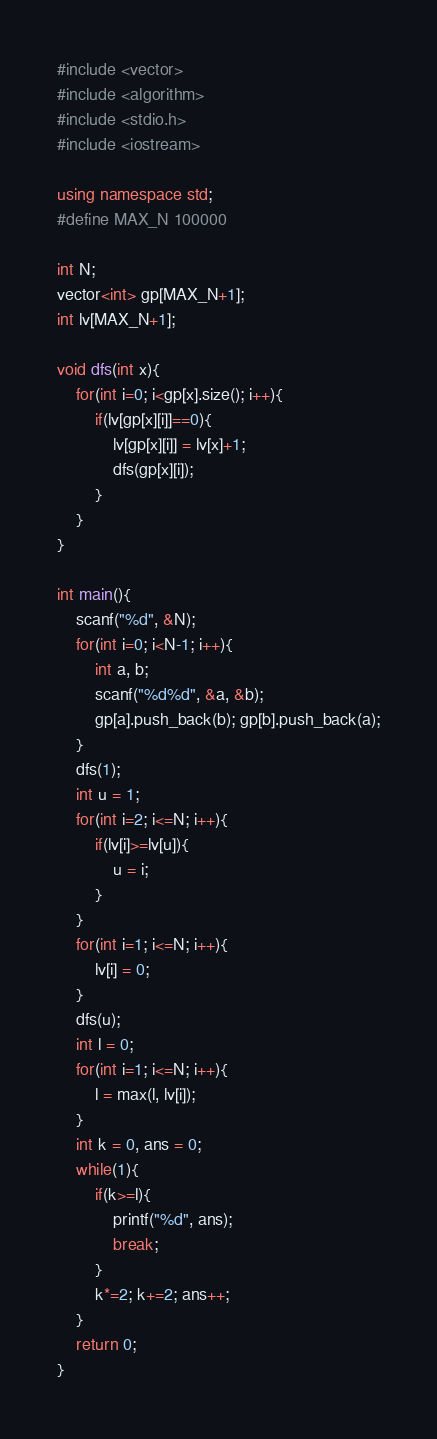Convert code to text. <code><loc_0><loc_0><loc_500><loc_500><_C++_>#include <vector>
#include <algorithm>
#include <stdio.h>
#include <iostream>

using namespace std;
#define MAX_N 100000

int N;
vector<int> gp[MAX_N+1];
int lv[MAX_N+1];

void dfs(int x){
	for(int i=0; i<gp[x].size(); i++){
		if(lv[gp[x][i]]==0){
			lv[gp[x][i]] = lv[x]+1;
			dfs(gp[x][i]);
		}
	}
}

int main(){
	scanf("%d", &N);
	for(int i=0; i<N-1; i++){
		int a, b;
		scanf("%d%d", &a, &b);
		gp[a].push_back(b); gp[b].push_back(a);
	}
	dfs(1);
	int u = 1;
	for(int i=2; i<=N; i++){
		if(lv[i]>=lv[u]){
			u = i;
		}
	}
	for(int i=1; i<=N; i++){
		lv[i] = 0;
	}
	dfs(u);
	int l = 0;
	for(int i=1; i<=N; i++){
		l = max(l, lv[i]);
	}
	int k = 0, ans = 0;
	while(1){
		if(k>=l){
			printf("%d", ans);
			break;
		}
		k*=2; k+=2; ans++;
	}
	return 0;
}</code> 